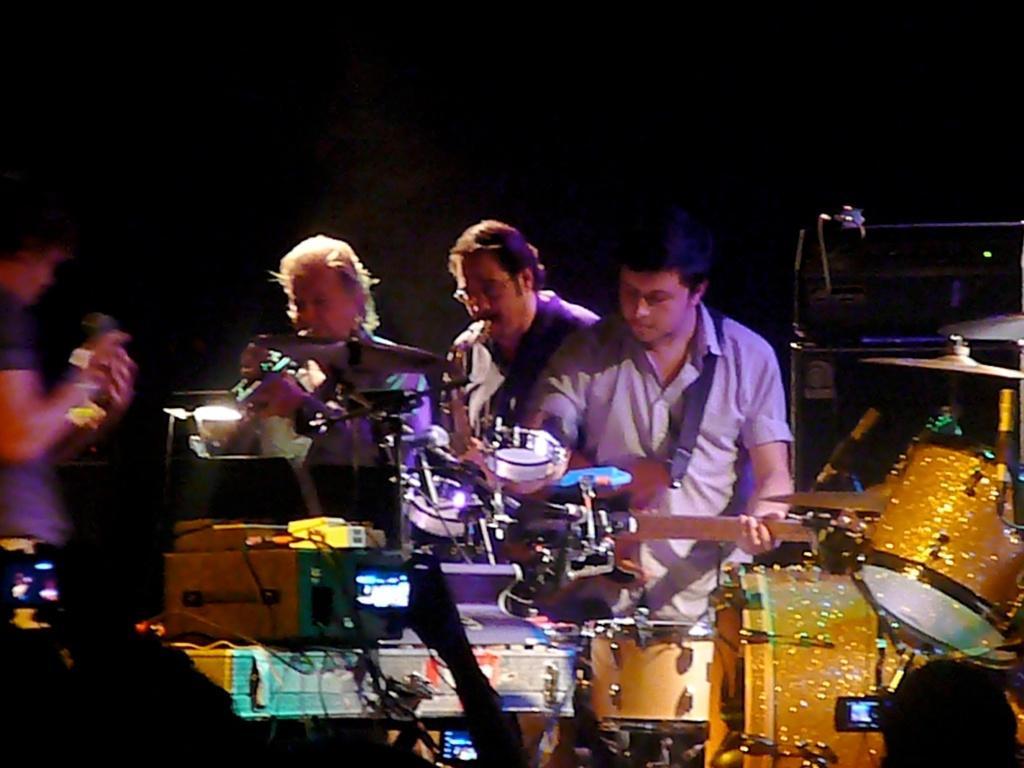In one or two sentences, can you explain what this image depicts? In the picture we can find some people are playing musical instruments and in the background there is a dark shade. 